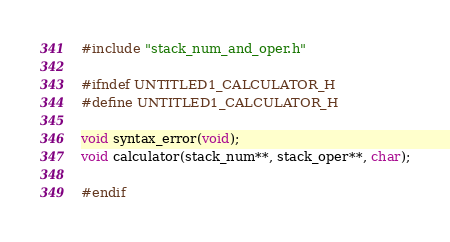<code> <loc_0><loc_0><loc_500><loc_500><_C_>#include "stack_num_and_oper.h"

#ifndef UNTITLED1_CALCULATOR_H
#define UNTITLED1_CALCULATOR_H

void syntax_error(void);
void calculator(stack_num**, stack_oper**, char);

#endif
</code> 